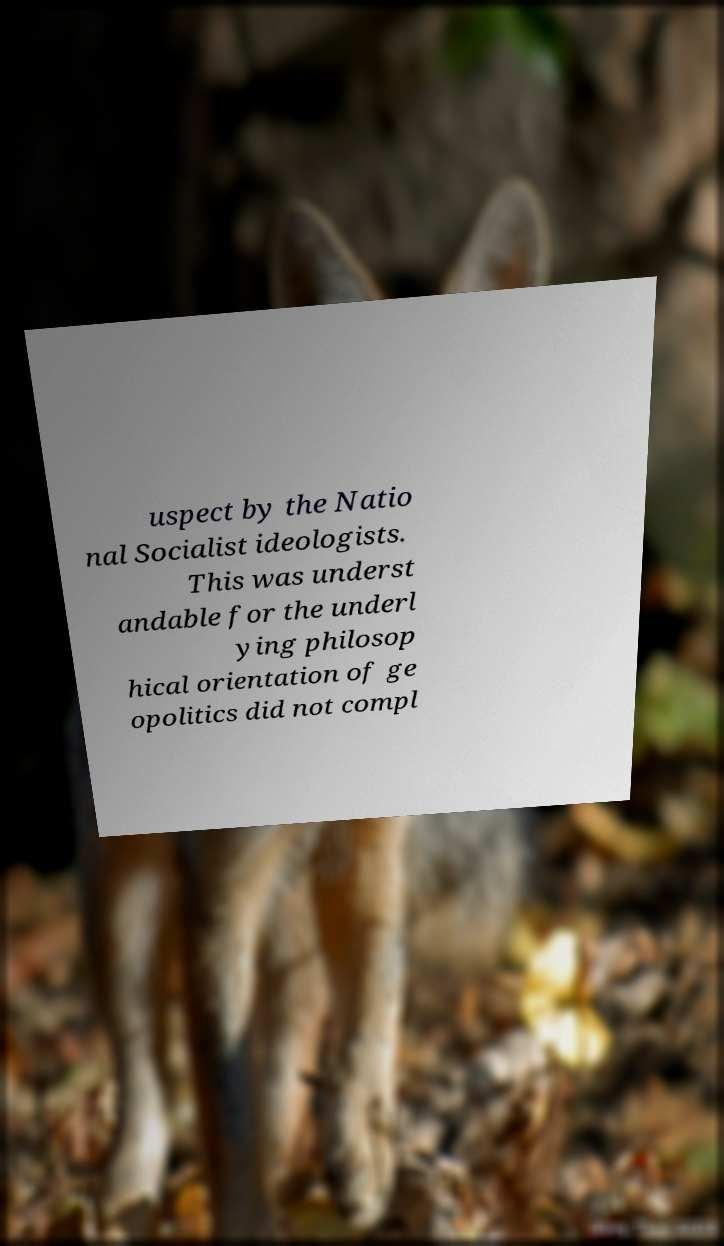Please identify and transcribe the text found in this image. uspect by the Natio nal Socialist ideologists. This was underst andable for the underl ying philosop hical orientation of ge opolitics did not compl 